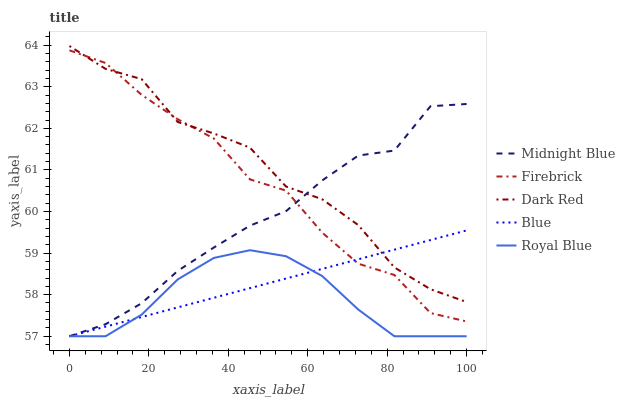Does Royal Blue have the minimum area under the curve?
Answer yes or no. Yes. Does Dark Red have the maximum area under the curve?
Answer yes or no. Yes. Does Firebrick have the minimum area under the curve?
Answer yes or no. No. Does Firebrick have the maximum area under the curve?
Answer yes or no. No. Is Blue the smoothest?
Answer yes or no. Yes. Is Firebrick the roughest?
Answer yes or no. Yes. Is Dark Red the smoothest?
Answer yes or no. No. Is Dark Red the roughest?
Answer yes or no. No. Does Firebrick have the lowest value?
Answer yes or no. No. Does Dark Red have the highest value?
Answer yes or no. Yes. Does Firebrick have the highest value?
Answer yes or no. No. Is Royal Blue less than Firebrick?
Answer yes or no. Yes. Is Dark Red greater than Royal Blue?
Answer yes or no. Yes. Does Blue intersect Dark Red?
Answer yes or no. Yes. Is Blue less than Dark Red?
Answer yes or no. No. Is Blue greater than Dark Red?
Answer yes or no. No. Does Royal Blue intersect Firebrick?
Answer yes or no. No. 